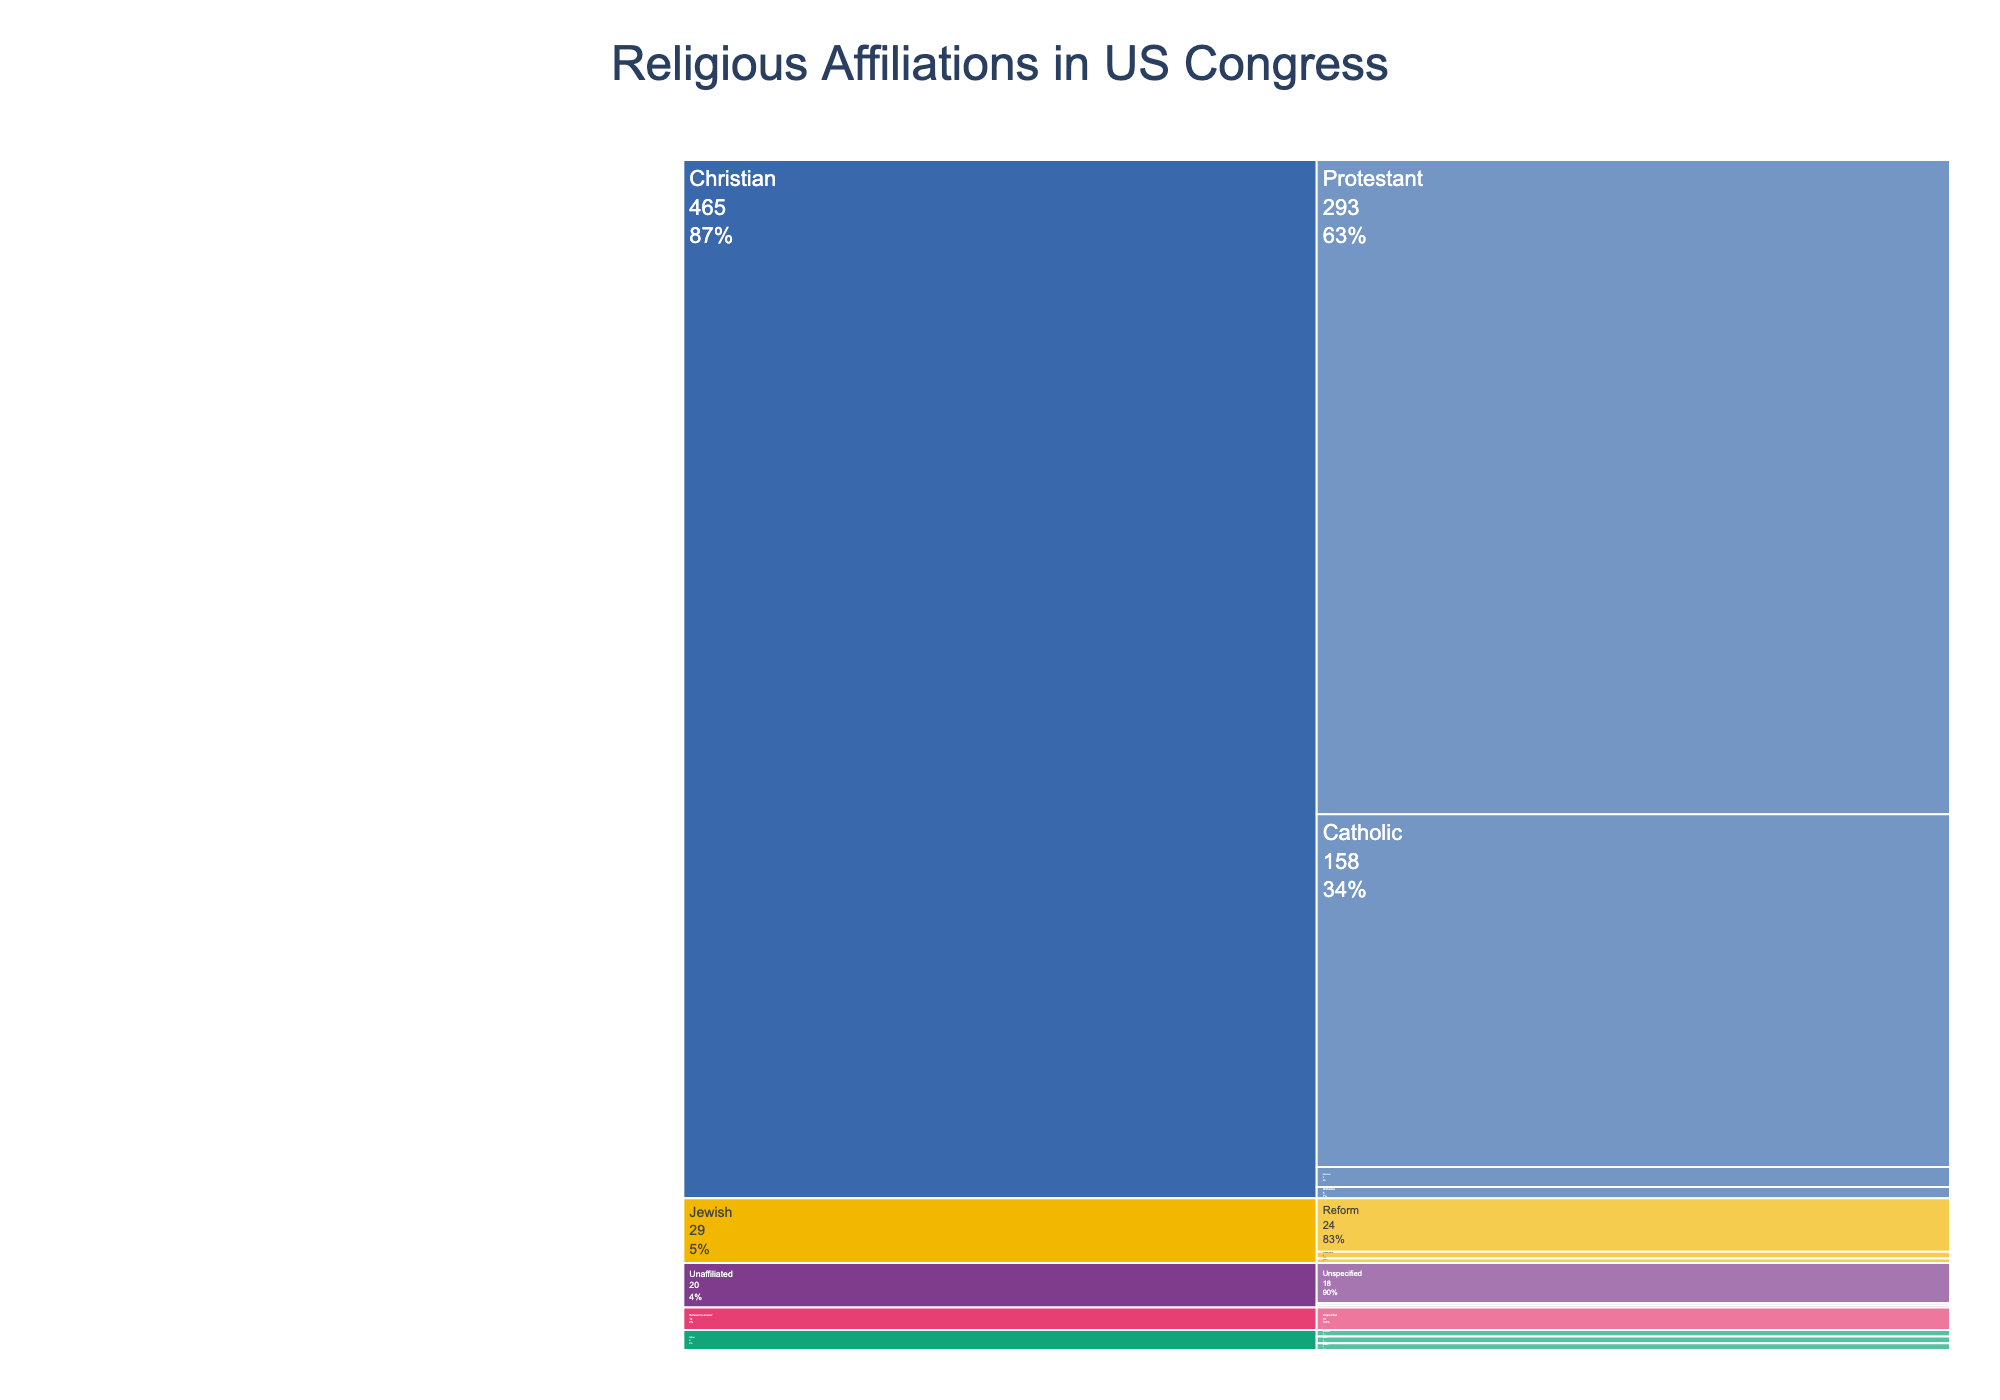What's the title of the chart? The title is displayed prominently at the top center of the chart.
Answer: Religious Affiliations in US Congress How many elected officials in the US Congress are Christians? Sum the numbers associated with all Christian denominations: 293 (Protestant) + 158 (Catholic) + 9 (Mormon) + 5 (Orthodox) = 465
Answer: 465 What percentage of US Congress identifies as Jewish? Sum the numbers for each Jewish denomination: 24 (Reform) + 3 (Conservative) + 2 (Orthodox) = 29. Then, calculate the percentage: (29/525) * 100 ≈ 5.5%
Answer: 5.5% Which non-Christian religion has the fewest representatives in US Congress? Compare the counts of Buddhist, Hindu, and Muslim officials. Each has 3 representatives, so they are all equal.
Answer: Buddhist, Hindu, and Muslim How many more Protestant Christians are there compared to all unaffiliated officials? Subtract the total number of unaffiliated officials (18 unassociated + 1 atheist + 1 agnostic = 20) from the number of Protestant Christians (293). 293 - 20 = 273
Answer: 273 What's the proportion of elected officials who refused to answer their religious affiliation? Divide the number who refused to answer (10) by the total number of officials (525) and multiply by 100: (10/525) * 100 ≈ 1.9%
Answer: 1.9% Which religious group has the highest representation in the US Congress? Compare the numbers for each religious group. Christian (465) has the highest count.
Answer: Christian How many religious affiliations are represented within the Christian group? Count the different denominations under the Christian category. There are 4: Protestant, Catholic, Mormon, and Orthodox.
Answer: 4 What is the combined total of officials identifying as "Other" religions and those "Unaffiliated"? Sum the counts of "Other" (3 Buddist + 3 Hindu + 3 Muslim = 9) and "Unaffiliated" (18 unspecified + 1 atheist + 1 agnostic = 20). 9 + 20 = 29
Answer: 29 